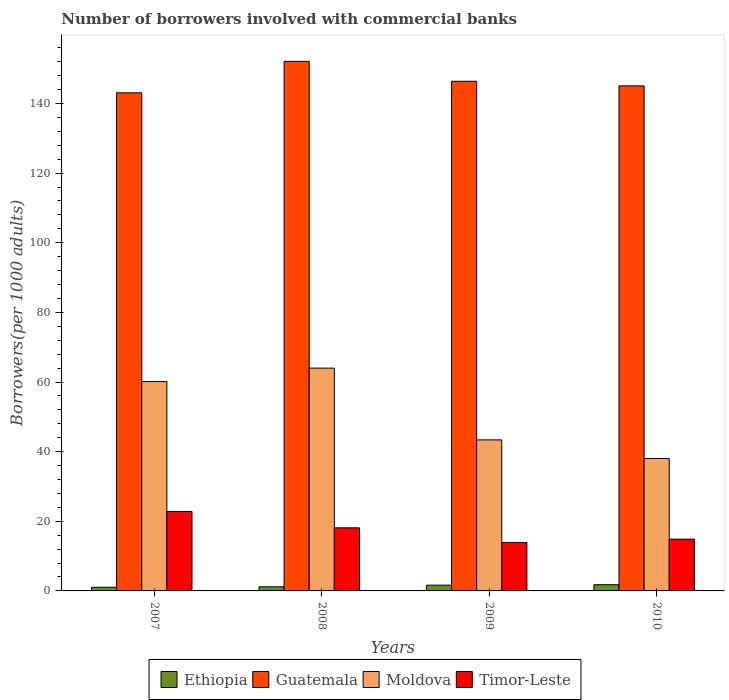How many different coloured bars are there?
Provide a succinct answer. 4. How many groups of bars are there?
Ensure brevity in your answer.  4. Are the number of bars per tick equal to the number of legend labels?
Keep it short and to the point. Yes. Are the number of bars on each tick of the X-axis equal?
Keep it short and to the point. Yes. How many bars are there on the 4th tick from the left?
Your answer should be compact. 4. How many bars are there on the 4th tick from the right?
Ensure brevity in your answer.  4. What is the number of borrowers involved with commercial banks in Timor-Leste in 2010?
Make the answer very short. 14.87. Across all years, what is the maximum number of borrowers involved with commercial banks in Ethiopia?
Your answer should be very brief. 1.78. Across all years, what is the minimum number of borrowers involved with commercial banks in Ethiopia?
Your response must be concise. 1.05. In which year was the number of borrowers involved with commercial banks in Guatemala minimum?
Offer a terse response. 2007. What is the total number of borrowers involved with commercial banks in Moldova in the graph?
Provide a succinct answer. 205.54. What is the difference between the number of borrowers involved with commercial banks in Guatemala in 2007 and that in 2010?
Ensure brevity in your answer.  -1.99. What is the difference between the number of borrowers involved with commercial banks in Timor-Leste in 2008 and the number of borrowers involved with commercial banks in Moldova in 2007?
Provide a succinct answer. -42.01. What is the average number of borrowers involved with commercial banks in Moldova per year?
Offer a terse response. 51.38. In the year 2007, what is the difference between the number of borrowers involved with commercial banks in Guatemala and number of borrowers involved with commercial banks in Timor-Leste?
Your answer should be very brief. 120.24. In how many years, is the number of borrowers involved with commercial banks in Timor-Leste greater than 84?
Your response must be concise. 0. What is the ratio of the number of borrowers involved with commercial banks in Moldova in 2007 to that in 2009?
Your answer should be compact. 1.39. Is the number of borrowers involved with commercial banks in Timor-Leste in 2007 less than that in 2008?
Make the answer very short. No. Is the difference between the number of borrowers involved with commercial banks in Guatemala in 2007 and 2008 greater than the difference between the number of borrowers involved with commercial banks in Timor-Leste in 2007 and 2008?
Your response must be concise. No. What is the difference between the highest and the second highest number of borrowers involved with commercial banks in Timor-Leste?
Give a very brief answer. 4.69. What is the difference between the highest and the lowest number of borrowers involved with commercial banks in Timor-Leste?
Your answer should be very brief. 8.92. In how many years, is the number of borrowers involved with commercial banks in Moldova greater than the average number of borrowers involved with commercial banks in Moldova taken over all years?
Your response must be concise. 2. Is it the case that in every year, the sum of the number of borrowers involved with commercial banks in Moldova and number of borrowers involved with commercial banks in Guatemala is greater than the sum of number of borrowers involved with commercial banks in Ethiopia and number of borrowers involved with commercial banks in Timor-Leste?
Your answer should be very brief. Yes. What does the 1st bar from the left in 2008 represents?
Your answer should be compact. Ethiopia. What does the 1st bar from the right in 2008 represents?
Your response must be concise. Timor-Leste. Is it the case that in every year, the sum of the number of borrowers involved with commercial banks in Guatemala and number of borrowers involved with commercial banks in Ethiopia is greater than the number of borrowers involved with commercial banks in Timor-Leste?
Offer a very short reply. Yes. Are all the bars in the graph horizontal?
Give a very brief answer. No. How many years are there in the graph?
Offer a very short reply. 4. Does the graph contain any zero values?
Your response must be concise. No. Where does the legend appear in the graph?
Keep it short and to the point. Bottom center. What is the title of the graph?
Provide a succinct answer. Number of borrowers involved with commercial banks. What is the label or title of the Y-axis?
Offer a very short reply. Borrowers(per 1000 adults). What is the Borrowers(per 1000 adults) in Ethiopia in 2007?
Your response must be concise. 1.05. What is the Borrowers(per 1000 adults) of Guatemala in 2007?
Offer a terse response. 143.06. What is the Borrowers(per 1000 adults) of Moldova in 2007?
Your answer should be very brief. 60.13. What is the Borrowers(per 1000 adults) of Timor-Leste in 2007?
Keep it short and to the point. 22.82. What is the Borrowers(per 1000 adults) in Ethiopia in 2008?
Ensure brevity in your answer.  1.18. What is the Borrowers(per 1000 adults) in Guatemala in 2008?
Provide a succinct answer. 152.09. What is the Borrowers(per 1000 adults) of Moldova in 2008?
Your answer should be compact. 63.99. What is the Borrowers(per 1000 adults) of Timor-Leste in 2008?
Keep it short and to the point. 18.13. What is the Borrowers(per 1000 adults) of Ethiopia in 2009?
Make the answer very short. 1.65. What is the Borrowers(per 1000 adults) of Guatemala in 2009?
Keep it short and to the point. 146.37. What is the Borrowers(per 1000 adults) in Moldova in 2009?
Keep it short and to the point. 43.38. What is the Borrowers(per 1000 adults) in Timor-Leste in 2009?
Offer a very short reply. 13.9. What is the Borrowers(per 1000 adults) of Ethiopia in 2010?
Your answer should be compact. 1.78. What is the Borrowers(per 1000 adults) of Guatemala in 2010?
Your response must be concise. 145.05. What is the Borrowers(per 1000 adults) of Moldova in 2010?
Offer a terse response. 38.03. What is the Borrowers(per 1000 adults) of Timor-Leste in 2010?
Provide a short and direct response. 14.87. Across all years, what is the maximum Borrowers(per 1000 adults) of Ethiopia?
Give a very brief answer. 1.78. Across all years, what is the maximum Borrowers(per 1000 adults) in Guatemala?
Your response must be concise. 152.09. Across all years, what is the maximum Borrowers(per 1000 adults) of Moldova?
Offer a very short reply. 63.99. Across all years, what is the maximum Borrowers(per 1000 adults) in Timor-Leste?
Ensure brevity in your answer.  22.82. Across all years, what is the minimum Borrowers(per 1000 adults) of Ethiopia?
Offer a very short reply. 1.05. Across all years, what is the minimum Borrowers(per 1000 adults) in Guatemala?
Offer a very short reply. 143.06. Across all years, what is the minimum Borrowers(per 1000 adults) of Moldova?
Your answer should be compact. 38.03. Across all years, what is the minimum Borrowers(per 1000 adults) of Timor-Leste?
Provide a succinct answer. 13.9. What is the total Borrowers(per 1000 adults) in Ethiopia in the graph?
Ensure brevity in your answer.  5.67. What is the total Borrowers(per 1000 adults) of Guatemala in the graph?
Give a very brief answer. 586.58. What is the total Borrowers(per 1000 adults) in Moldova in the graph?
Provide a short and direct response. 205.54. What is the total Borrowers(per 1000 adults) in Timor-Leste in the graph?
Your answer should be compact. 69.72. What is the difference between the Borrowers(per 1000 adults) of Ethiopia in 2007 and that in 2008?
Offer a very short reply. -0.13. What is the difference between the Borrowers(per 1000 adults) of Guatemala in 2007 and that in 2008?
Offer a terse response. -9.03. What is the difference between the Borrowers(per 1000 adults) in Moldova in 2007 and that in 2008?
Your response must be concise. -3.86. What is the difference between the Borrowers(per 1000 adults) of Timor-Leste in 2007 and that in 2008?
Offer a very short reply. 4.69. What is the difference between the Borrowers(per 1000 adults) of Ethiopia in 2007 and that in 2009?
Ensure brevity in your answer.  -0.6. What is the difference between the Borrowers(per 1000 adults) in Guatemala in 2007 and that in 2009?
Keep it short and to the point. -3.31. What is the difference between the Borrowers(per 1000 adults) in Moldova in 2007 and that in 2009?
Your answer should be compact. 16.76. What is the difference between the Borrowers(per 1000 adults) in Timor-Leste in 2007 and that in 2009?
Offer a terse response. 8.92. What is the difference between the Borrowers(per 1000 adults) in Ethiopia in 2007 and that in 2010?
Offer a very short reply. -0.73. What is the difference between the Borrowers(per 1000 adults) in Guatemala in 2007 and that in 2010?
Ensure brevity in your answer.  -1.99. What is the difference between the Borrowers(per 1000 adults) of Moldova in 2007 and that in 2010?
Your response must be concise. 22.1. What is the difference between the Borrowers(per 1000 adults) in Timor-Leste in 2007 and that in 2010?
Your answer should be very brief. 7.95. What is the difference between the Borrowers(per 1000 adults) in Ethiopia in 2008 and that in 2009?
Provide a succinct answer. -0.47. What is the difference between the Borrowers(per 1000 adults) of Guatemala in 2008 and that in 2009?
Your answer should be very brief. 5.72. What is the difference between the Borrowers(per 1000 adults) in Moldova in 2008 and that in 2009?
Your answer should be compact. 20.61. What is the difference between the Borrowers(per 1000 adults) in Timor-Leste in 2008 and that in 2009?
Make the answer very short. 4.22. What is the difference between the Borrowers(per 1000 adults) of Ethiopia in 2008 and that in 2010?
Ensure brevity in your answer.  -0.6. What is the difference between the Borrowers(per 1000 adults) of Guatemala in 2008 and that in 2010?
Give a very brief answer. 7.04. What is the difference between the Borrowers(per 1000 adults) in Moldova in 2008 and that in 2010?
Provide a short and direct response. 25.95. What is the difference between the Borrowers(per 1000 adults) of Timor-Leste in 2008 and that in 2010?
Keep it short and to the point. 3.25. What is the difference between the Borrowers(per 1000 adults) of Ethiopia in 2009 and that in 2010?
Offer a very short reply. -0.13. What is the difference between the Borrowers(per 1000 adults) of Guatemala in 2009 and that in 2010?
Your answer should be compact. 1.32. What is the difference between the Borrowers(per 1000 adults) in Moldova in 2009 and that in 2010?
Offer a very short reply. 5.34. What is the difference between the Borrowers(per 1000 adults) in Timor-Leste in 2009 and that in 2010?
Give a very brief answer. -0.97. What is the difference between the Borrowers(per 1000 adults) of Ethiopia in 2007 and the Borrowers(per 1000 adults) of Guatemala in 2008?
Your response must be concise. -151.04. What is the difference between the Borrowers(per 1000 adults) of Ethiopia in 2007 and the Borrowers(per 1000 adults) of Moldova in 2008?
Offer a terse response. -62.94. What is the difference between the Borrowers(per 1000 adults) in Ethiopia in 2007 and the Borrowers(per 1000 adults) in Timor-Leste in 2008?
Provide a succinct answer. -17.07. What is the difference between the Borrowers(per 1000 adults) of Guatemala in 2007 and the Borrowers(per 1000 adults) of Moldova in 2008?
Ensure brevity in your answer.  79.07. What is the difference between the Borrowers(per 1000 adults) of Guatemala in 2007 and the Borrowers(per 1000 adults) of Timor-Leste in 2008?
Your response must be concise. 124.93. What is the difference between the Borrowers(per 1000 adults) of Moldova in 2007 and the Borrowers(per 1000 adults) of Timor-Leste in 2008?
Give a very brief answer. 42.01. What is the difference between the Borrowers(per 1000 adults) in Ethiopia in 2007 and the Borrowers(per 1000 adults) in Guatemala in 2009?
Your response must be concise. -145.32. What is the difference between the Borrowers(per 1000 adults) of Ethiopia in 2007 and the Borrowers(per 1000 adults) of Moldova in 2009?
Your response must be concise. -42.32. What is the difference between the Borrowers(per 1000 adults) in Ethiopia in 2007 and the Borrowers(per 1000 adults) in Timor-Leste in 2009?
Provide a succinct answer. -12.85. What is the difference between the Borrowers(per 1000 adults) in Guatemala in 2007 and the Borrowers(per 1000 adults) in Moldova in 2009?
Make the answer very short. 99.68. What is the difference between the Borrowers(per 1000 adults) of Guatemala in 2007 and the Borrowers(per 1000 adults) of Timor-Leste in 2009?
Keep it short and to the point. 129.16. What is the difference between the Borrowers(per 1000 adults) in Moldova in 2007 and the Borrowers(per 1000 adults) in Timor-Leste in 2009?
Make the answer very short. 46.23. What is the difference between the Borrowers(per 1000 adults) of Ethiopia in 2007 and the Borrowers(per 1000 adults) of Guatemala in 2010?
Ensure brevity in your answer.  -144. What is the difference between the Borrowers(per 1000 adults) in Ethiopia in 2007 and the Borrowers(per 1000 adults) in Moldova in 2010?
Your response must be concise. -36.98. What is the difference between the Borrowers(per 1000 adults) in Ethiopia in 2007 and the Borrowers(per 1000 adults) in Timor-Leste in 2010?
Offer a very short reply. -13.82. What is the difference between the Borrowers(per 1000 adults) of Guatemala in 2007 and the Borrowers(per 1000 adults) of Moldova in 2010?
Offer a terse response. 105.03. What is the difference between the Borrowers(per 1000 adults) in Guatemala in 2007 and the Borrowers(per 1000 adults) in Timor-Leste in 2010?
Give a very brief answer. 128.19. What is the difference between the Borrowers(per 1000 adults) of Moldova in 2007 and the Borrowers(per 1000 adults) of Timor-Leste in 2010?
Provide a short and direct response. 45.26. What is the difference between the Borrowers(per 1000 adults) in Ethiopia in 2008 and the Borrowers(per 1000 adults) in Guatemala in 2009?
Provide a succinct answer. -145.19. What is the difference between the Borrowers(per 1000 adults) of Ethiopia in 2008 and the Borrowers(per 1000 adults) of Moldova in 2009?
Offer a terse response. -42.2. What is the difference between the Borrowers(per 1000 adults) of Ethiopia in 2008 and the Borrowers(per 1000 adults) of Timor-Leste in 2009?
Keep it short and to the point. -12.72. What is the difference between the Borrowers(per 1000 adults) in Guatemala in 2008 and the Borrowers(per 1000 adults) in Moldova in 2009?
Ensure brevity in your answer.  108.72. What is the difference between the Borrowers(per 1000 adults) of Guatemala in 2008 and the Borrowers(per 1000 adults) of Timor-Leste in 2009?
Offer a terse response. 138.19. What is the difference between the Borrowers(per 1000 adults) in Moldova in 2008 and the Borrowers(per 1000 adults) in Timor-Leste in 2009?
Offer a terse response. 50.09. What is the difference between the Borrowers(per 1000 adults) in Ethiopia in 2008 and the Borrowers(per 1000 adults) in Guatemala in 2010?
Keep it short and to the point. -143.87. What is the difference between the Borrowers(per 1000 adults) of Ethiopia in 2008 and the Borrowers(per 1000 adults) of Moldova in 2010?
Provide a succinct answer. -36.85. What is the difference between the Borrowers(per 1000 adults) in Ethiopia in 2008 and the Borrowers(per 1000 adults) in Timor-Leste in 2010?
Give a very brief answer. -13.69. What is the difference between the Borrowers(per 1000 adults) in Guatemala in 2008 and the Borrowers(per 1000 adults) in Moldova in 2010?
Your response must be concise. 114.06. What is the difference between the Borrowers(per 1000 adults) in Guatemala in 2008 and the Borrowers(per 1000 adults) in Timor-Leste in 2010?
Offer a very short reply. 137.22. What is the difference between the Borrowers(per 1000 adults) of Moldova in 2008 and the Borrowers(per 1000 adults) of Timor-Leste in 2010?
Ensure brevity in your answer.  49.12. What is the difference between the Borrowers(per 1000 adults) of Ethiopia in 2009 and the Borrowers(per 1000 adults) of Guatemala in 2010?
Your answer should be compact. -143.4. What is the difference between the Borrowers(per 1000 adults) in Ethiopia in 2009 and the Borrowers(per 1000 adults) in Moldova in 2010?
Give a very brief answer. -36.38. What is the difference between the Borrowers(per 1000 adults) in Ethiopia in 2009 and the Borrowers(per 1000 adults) in Timor-Leste in 2010?
Your response must be concise. -13.22. What is the difference between the Borrowers(per 1000 adults) in Guatemala in 2009 and the Borrowers(per 1000 adults) in Moldova in 2010?
Give a very brief answer. 108.34. What is the difference between the Borrowers(per 1000 adults) in Guatemala in 2009 and the Borrowers(per 1000 adults) in Timor-Leste in 2010?
Offer a terse response. 131.5. What is the difference between the Borrowers(per 1000 adults) of Moldova in 2009 and the Borrowers(per 1000 adults) of Timor-Leste in 2010?
Offer a terse response. 28.51. What is the average Borrowers(per 1000 adults) of Ethiopia per year?
Your answer should be compact. 1.42. What is the average Borrowers(per 1000 adults) of Guatemala per year?
Ensure brevity in your answer.  146.64. What is the average Borrowers(per 1000 adults) of Moldova per year?
Your answer should be compact. 51.38. What is the average Borrowers(per 1000 adults) of Timor-Leste per year?
Provide a succinct answer. 17.43. In the year 2007, what is the difference between the Borrowers(per 1000 adults) of Ethiopia and Borrowers(per 1000 adults) of Guatemala?
Provide a short and direct response. -142.01. In the year 2007, what is the difference between the Borrowers(per 1000 adults) in Ethiopia and Borrowers(per 1000 adults) in Moldova?
Offer a very short reply. -59.08. In the year 2007, what is the difference between the Borrowers(per 1000 adults) in Ethiopia and Borrowers(per 1000 adults) in Timor-Leste?
Ensure brevity in your answer.  -21.77. In the year 2007, what is the difference between the Borrowers(per 1000 adults) of Guatemala and Borrowers(per 1000 adults) of Moldova?
Your answer should be very brief. 82.93. In the year 2007, what is the difference between the Borrowers(per 1000 adults) of Guatemala and Borrowers(per 1000 adults) of Timor-Leste?
Offer a very short reply. 120.24. In the year 2007, what is the difference between the Borrowers(per 1000 adults) in Moldova and Borrowers(per 1000 adults) in Timor-Leste?
Your response must be concise. 37.31. In the year 2008, what is the difference between the Borrowers(per 1000 adults) in Ethiopia and Borrowers(per 1000 adults) in Guatemala?
Ensure brevity in your answer.  -150.91. In the year 2008, what is the difference between the Borrowers(per 1000 adults) in Ethiopia and Borrowers(per 1000 adults) in Moldova?
Provide a short and direct response. -62.81. In the year 2008, what is the difference between the Borrowers(per 1000 adults) in Ethiopia and Borrowers(per 1000 adults) in Timor-Leste?
Keep it short and to the point. -16.94. In the year 2008, what is the difference between the Borrowers(per 1000 adults) in Guatemala and Borrowers(per 1000 adults) in Moldova?
Give a very brief answer. 88.11. In the year 2008, what is the difference between the Borrowers(per 1000 adults) of Guatemala and Borrowers(per 1000 adults) of Timor-Leste?
Your answer should be compact. 133.97. In the year 2008, what is the difference between the Borrowers(per 1000 adults) of Moldova and Borrowers(per 1000 adults) of Timor-Leste?
Ensure brevity in your answer.  45.86. In the year 2009, what is the difference between the Borrowers(per 1000 adults) in Ethiopia and Borrowers(per 1000 adults) in Guatemala?
Provide a short and direct response. -144.72. In the year 2009, what is the difference between the Borrowers(per 1000 adults) in Ethiopia and Borrowers(per 1000 adults) in Moldova?
Your answer should be very brief. -41.73. In the year 2009, what is the difference between the Borrowers(per 1000 adults) of Ethiopia and Borrowers(per 1000 adults) of Timor-Leste?
Keep it short and to the point. -12.25. In the year 2009, what is the difference between the Borrowers(per 1000 adults) of Guatemala and Borrowers(per 1000 adults) of Moldova?
Make the answer very short. 102.99. In the year 2009, what is the difference between the Borrowers(per 1000 adults) of Guatemala and Borrowers(per 1000 adults) of Timor-Leste?
Provide a short and direct response. 132.47. In the year 2009, what is the difference between the Borrowers(per 1000 adults) in Moldova and Borrowers(per 1000 adults) in Timor-Leste?
Offer a very short reply. 29.47. In the year 2010, what is the difference between the Borrowers(per 1000 adults) in Ethiopia and Borrowers(per 1000 adults) in Guatemala?
Provide a short and direct response. -143.27. In the year 2010, what is the difference between the Borrowers(per 1000 adults) in Ethiopia and Borrowers(per 1000 adults) in Moldova?
Ensure brevity in your answer.  -36.25. In the year 2010, what is the difference between the Borrowers(per 1000 adults) of Ethiopia and Borrowers(per 1000 adults) of Timor-Leste?
Offer a terse response. -13.09. In the year 2010, what is the difference between the Borrowers(per 1000 adults) in Guatemala and Borrowers(per 1000 adults) in Moldova?
Ensure brevity in your answer.  107.02. In the year 2010, what is the difference between the Borrowers(per 1000 adults) in Guatemala and Borrowers(per 1000 adults) in Timor-Leste?
Offer a terse response. 130.18. In the year 2010, what is the difference between the Borrowers(per 1000 adults) of Moldova and Borrowers(per 1000 adults) of Timor-Leste?
Your response must be concise. 23.16. What is the ratio of the Borrowers(per 1000 adults) in Ethiopia in 2007 to that in 2008?
Provide a short and direct response. 0.89. What is the ratio of the Borrowers(per 1000 adults) in Guatemala in 2007 to that in 2008?
Give a very brief answer. 0.94. What is the ratio of the Borrowers(per 1000 adults) of Moldova in 2007 to that in 2008?
Your response must be concise. 0.94. What is the ratio of the Borrowers(per 1000 adults) of Timor-Leste in 2007 to that in 2008?
Your response must be concise. 1.26. What is the ratio of the Borrowers(per 1000 adults) in Ethiopia in 2007 to that in 2009?
Your answer should be very brief. 0.64. What is the ratio of the Borrowers(per 1000 adults) of Guatemala in 2007 to that in 2009?
Ensure brevity in your answer.  0.98. What is the ratio of the Borrowers(per 1000 adults) of Moldova in 2007 to that in 2009?
Offer a terse response. 1.39. What is the ratio of the Borrowers(per 1000 adults) of Timor-Leste in 2007 to that in 2009?
Your response must be concise. 1.64. What is the ratio of the Borrowers(per 1000 adults) in Ethiopia in 2007 to that in 2010?
Your answer should be compact. 0.59. What is the ratio of the Borrowers(per 1000 adults) of Guatemala in 2007 to that in 2010?
Offer a terse response. 0.99. What is the ratio of the Borrowers(per 1000 adults) in Moldova in 2007 to that in 2010?
Keep it short and to the point. 1.58. What is the ratio of the Borrowers(per 1000 adults) in Timor-Leste in 2007 to that in 2010?
Keep it short and to the point. 1.53. What is the ratio of the Borrowers(per 1000 adults) of Ethiopia in 2008 to that in 2009?
Offer a very short reply. 0.72. What is the ratio of the Borrowers(per 1000 adults) of Guatemala in 2008 to that in 2009?
Your answer should be very brief. 1.04. What is the ratio of the Borrowers(per 1000 adults) in Moldova in 2008 to that in 2009?
Offer a very short reply. 1.48. What is the ratio of the Borrowers(per 1000 adults) of Timor-Leste in 2008 to that in 2009?
Keep it short and to the point. 1.3. What is the ratio of the Borrowers(per 1000 adults) in Ethiopia in 2008 to that in 2010?
Offer a very short reply. 0.66. What is the ratio of the Borrowers(per 1000 adults) in Guatemala in 2008 to that in 2010?
Make the answer very short. 1.05. What is the ratio of the Borrowers(per 1000 adults) in Moldova in 2008 to that in 2010?
Provide a short and direct response. 1.68. What is the ratio of the Borrowers(per 1000 adults) of Timor-Leste in 2008 to that in 2010?
Your answer should be very brief. 1.22. What is the ratio of the Borrowers(per 1000 adults) of Ethiopia in 2009 to that in 2010?
Your answer should be compact. 0.93. What is the ratio of the Borrowers(per 1000 adults) of Guatemala in 2009 to that in 2010?
Offer a very short reply. 1.01. What is the ratio of the Borrowers(per 1000 adults) of Moldova in 2009 to that in 2010?
Provide a short and direct response. 1.14. What is the ratio of the Borrowers(per 1000 adults) of Timor-Leste in 2009 to that in 2010?
Provide a short and direct response. 0.94. What is the difference between the highest and the second highest Borrowers(per 1000 adults) of Ethiopia?
Ensure brevity in your answer.  0.13. What is the difference between the highest and the second highest Borrowers(per 1000 adults) in Guatemala?
Make the answer very short. 5.72. What is the difference between the highest and the second highest Borrowers(per 1000 adults) of Moldova?
Your response must be concise. 3.86. What is the difference between the highest and the second highest Borrowers(per 1000 adults) of Timor-Leste?
Your answer should be very brief. 4.69. What is the difference between the highest and the lowest Borrowers(per 1000 adults) in Ethiopia?
Offer a terse response. 0.73. What is the difference between the highest and the lowest Borrowers(per 1000 adults) in Guatemala?
Provide a succinct answer. 9.03. What is the difference between the highest and the lowest Borrowers(per 1000 adults) of Moldova?
Keep it short and to the point. 25.95. What is the difference between the highest and the lowest Borrowers(per 1000 adults) in Timor-Leste?
Offer a very short reply. 8.92. 